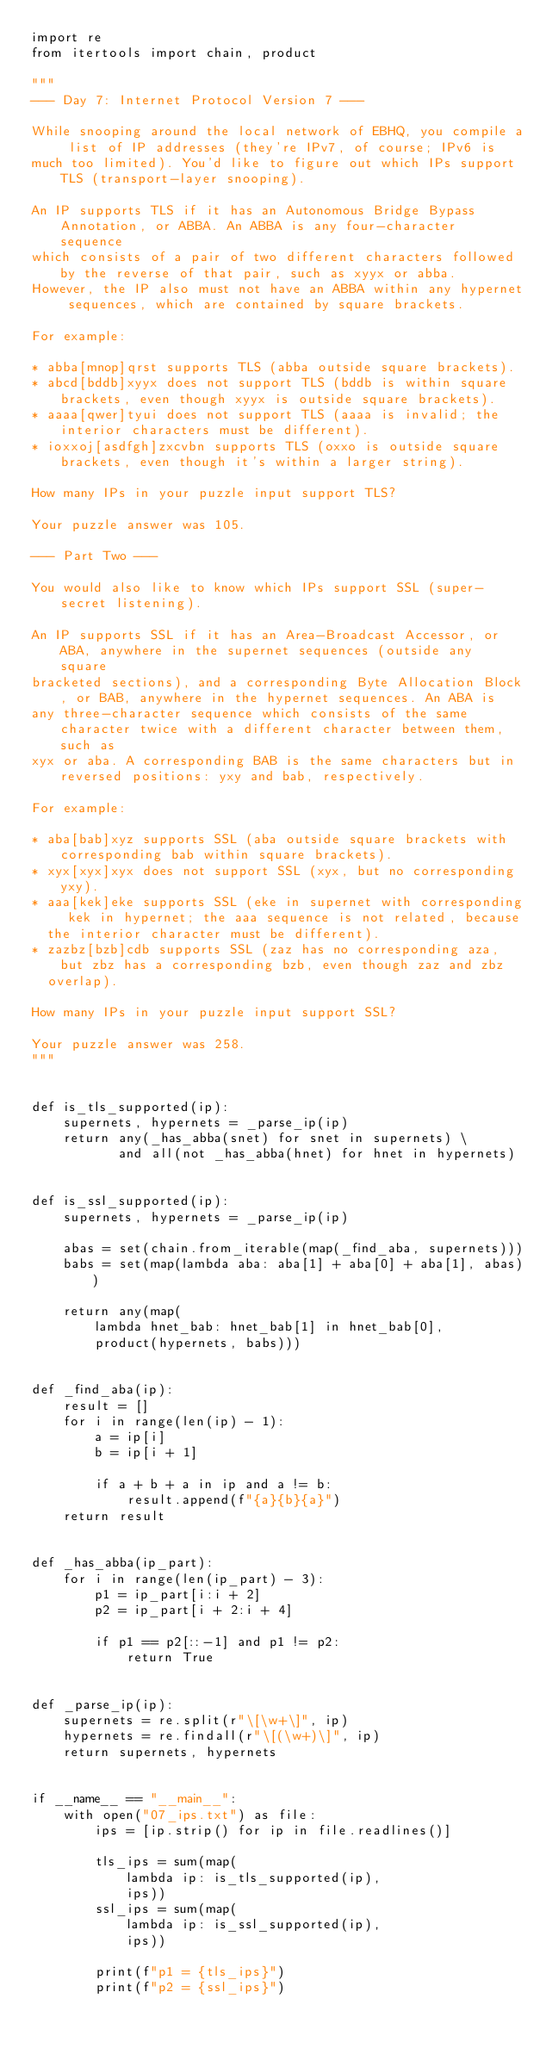<code> <loc_0><loc_0><loc_500><loc_500><_Python_>import re
from itertools import chain, product

"""
--- Day 7: Internet Protocol Version 7 ---

While snooping around the local network of EBHQ, you compile a list of IP addresses (they're IPv7, of course; IPv6 is
much too limited). You'd like to figure out which IPs support TLS (transport-layer snooping).

An IP supports TLS if it has an Autonomous Bridge Bypass Annotation, or ABBA. An ABBA is any four-character sequence
which consists of a pair of two different characters followed by the reverse of that pair, such as xyyx or abba.
However, the IP also must not have an ABBA within any hypernet sequences, which are contained by square brackets.

For example:

* abba[mnop]qrst supports TLS (abba outside square brackets).
* abcd[bddb]xyyx does not support TLS (bddb is within square brackets, even though xyyx is outside square brackets).
* aaaa[qwer]tyui does not support TLS (aaaa is invalid; the interior characters must be different).
* ioxxoj[asdfgh]zxcvbn supports TLS (oxxo is outside square brackets, even though it's within a larger string).

How many IPs in your puzzle input support TLS?

Your puzzle answer was 105.

--- Part Two ---

You would also like to know which IPs support SSL (super-secret listening).

An IP supports SSL if it has an Area-Broadcast Accessor, or ABA, anywhere in the supernet sequences (outside any square
bracketed sections), and a corresponding Byte Allocation Block, or BAB, anywhere in the hypernet sequences. An ABA is
any three-character sequence which consists of the same character twice with a different character between them, such as
xyx or aba. A corresponding BAB is the same characters but in reversed positions: yxy and bab, respectively.

For example:

* aba[bab]xyz supports SSL (aba outside square brackets with corresponding bab within square brackets).
* xyx[xyx]xyx does not support SSL (xyx, but no corresponding yxy).
* aaa[kek]eke supports SSL (eke in supernet with corresponding kek in hypernet; the aaa sequence is not related, because
  the interior character must be different).
* zazbz[bzb]cdb supports SSL (zaz has no corresponding aza, but zbz has a corresponding bzb, even though zaz and zbz
  overlap).

How many IPs in your puzzle input support SSL?

Your puzzle answer was 258.
"""


def is_tls_supported(ip):
    supernets, hypernets = _parse_ip(ip)
    return any(_has_abba(snet) for snet in supernets) \
           and all(not _has_abba(hnet) for hnet in hypernets)


def is_ssl_supported(ip):
    supernets, hypernets = _parse_ip(ip)

    abas = set(chain.from_iterable(map(_find_aba, supernets)))
    babs = set(map(lambda aba: aba[1] + aba[0] + aba[1], abas))

    return any(map(
        lambda hnet_bab: hnet_bab[1] in hnet_bab[0],
        product(hypernets, babs)))


def _find_aba(ip):
    result = []
    for i in range(len(ip) - 1):
        a = ip[i]
        b = ip[i + 1]

        if a + b + a in ip and a != b:
            result.append(f"{a}{b}{a}")
    return result


def _has_abba(ip_part):
    for i in range(len(ip_part) - 3):
        p1 = ip_part[i:i + 2]
        p2 = ip_part[i + 2:i + 4]

        if p1 == p2[::-1] and p1 != p2:
            return True


def _parse_ip(ip):
    supernets = re.split(r"\[\w+\]", ip)
    hypernets = re.findall(r"\[(\w+)\]", ip)
    return supernets, hypernets


if __name__ == "__main__":
    with open("07_ips.txt") as file:
        ips = [ip.strip() for ip in file.readlines()]

        tls_ips = sum(map(
            lambda ip: is_tls_supported(ip),
            ips))
        ssl_ips = sum(map(
            lambda ip: is_ssl_supported(ip),
            ips))

        print(f"p1 = {tls_ips}")
        print(f"p2 = {ssl_ips}")
</code> 